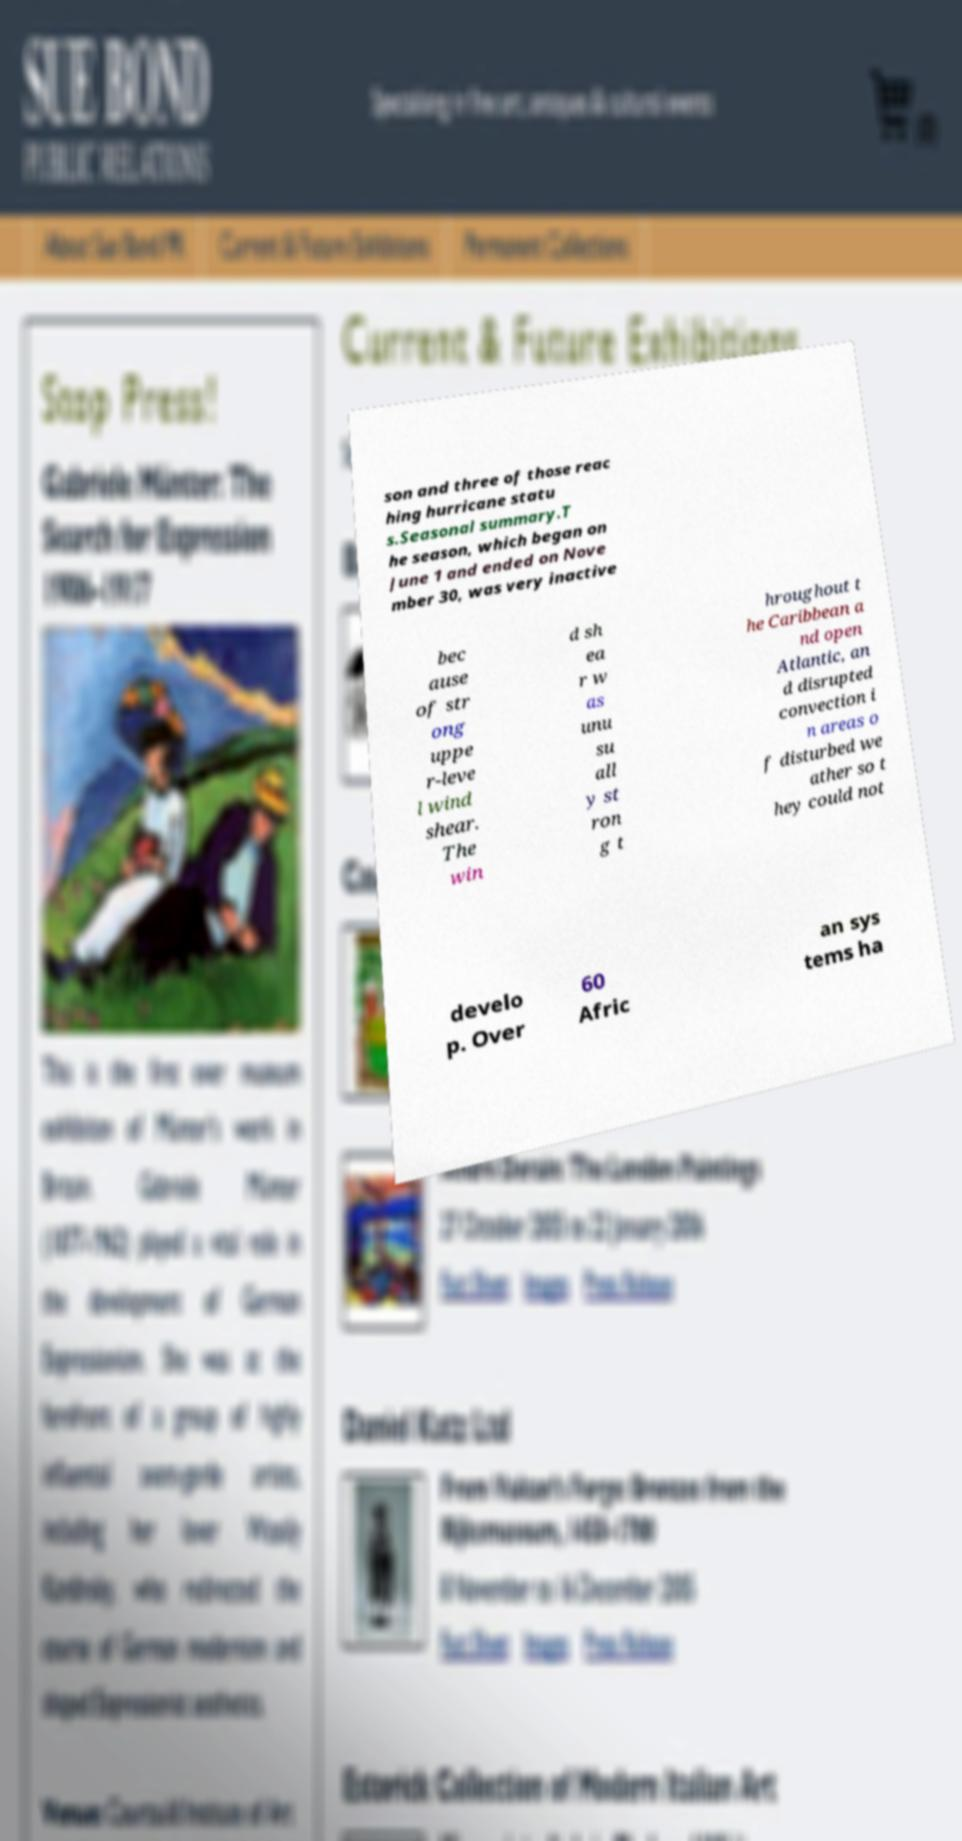What messages or text are displayed in this image? I need them in a readable, typed format. son and three of those reac hing hurricane statu s.Seasonal summary.T he season, which began on June 1 and ended on Nove mber 30, was very inactive bec ause of str ong uppe r-leve l wind shear. The win d sh ea r w as unu su all y st ron g t hroughout t he Caribbean a nd open Atlantic, an d disrupted convection i n areas o f disturbed we ather so t hey could not develo p. Over 60 Afric an sys tems ha 